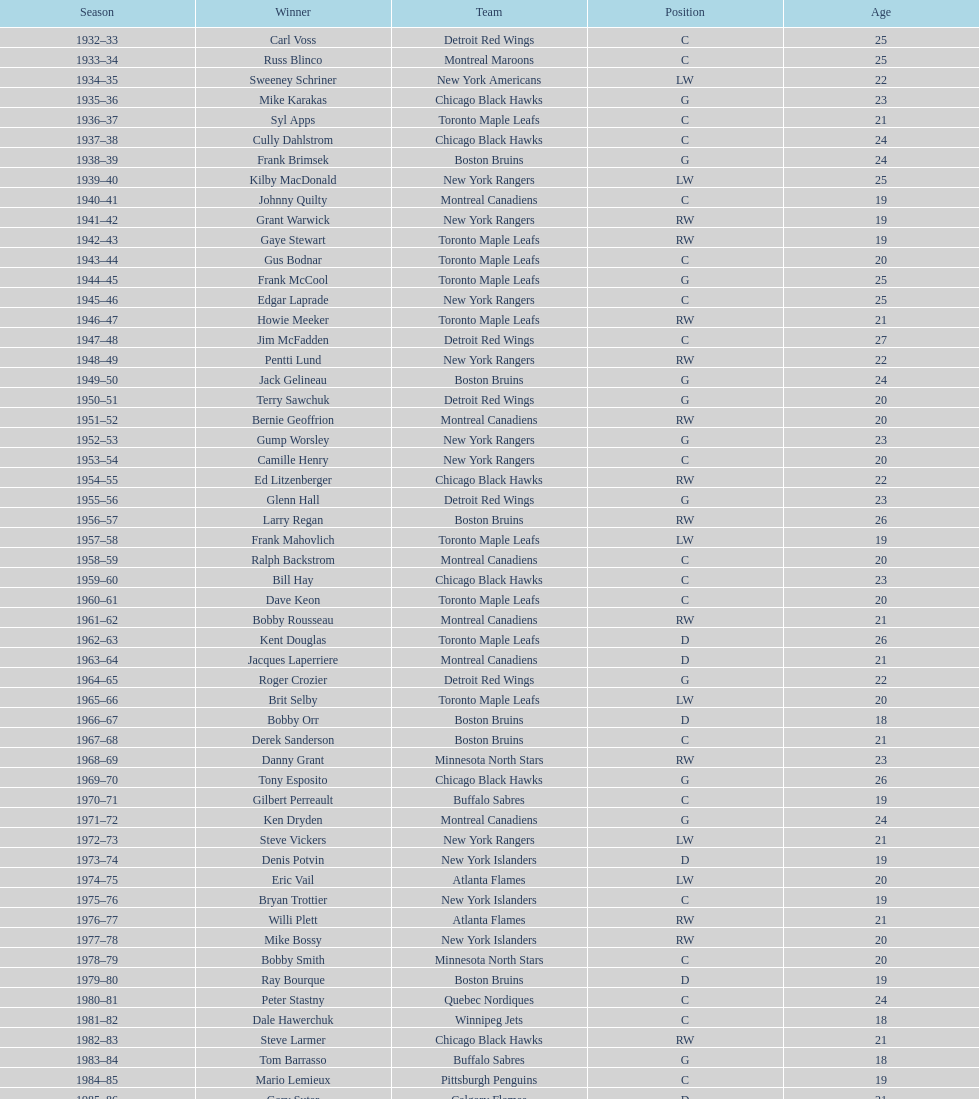What is the total number of toronto maple leafs' victories? 9. Give me the full table as a dictionary. {'header': ['Season', 'Winner', 'Team', 'Position', 'Age'], 'rows': [['1932–33', 'Carl Voss', 'Detroit Red Wings', 'C', '25'], ['1933–34', 'Russ Blinco', 'Montreal Maroons', 'C', '25'], ['1934–35', 'Sweeney Schriner', 'New York Americans', 'LW', '22'], ['1935–36', 'Mike Karakas', 'Chicago Black Hawks', 'G', '23'], ['1936–37', 'Syl Apps', 'Toronto Maple Leafs', 'C', '21'], ['1937–38', 'Cully Dahlstrom', 'Chicago Black Hawks', 'C', '24'], ['1938–39', 'Frank Brimsek', 'Boston Bruins', 'G', '24'], ['1939–40', 'Kilby MacDonald', 'New York Rangers', 'LW', '25'], ['1940–41', 'Johnny Quilty', 'Montreal Canadiens', 'C', '19'], ['1941–42', 'Grant Warwick', 'New York Rangers', 'RW', '19'], ['1942–43', 'Gaye Stewart', 'Toronto Maple Leafs', 'RW', '19'], ['1943–44', 'Gus Bodnar', 'Toronto Maple Leafs', 'C', '20'], ['1944–45', 'Frank McCool', 'Toronto Maple Leafs', 'G', '25'], ['1945–46', 'Edgar Laprade', 'New York Rangers', 'C', '25'], ['1946–47', 'Howie Meeker', 'Toronto Maple Leafs', 'RW', '21'], ['1947–48', 'Jim McFadden', 'Detroit Red Wings', 'C', '27'], ['1948–49', 'Pentti Lund', 'New York Rangers', 'RW', '22'], ['1949–50', 'Jack Gelineau', 'Boston Bruins', 'G', '24'], ['1950–51', 'Terry Sawchuk', 'Detroit Red Wings', 'G', '20'], ['1951–52', 'Bernie Geoffrion', 'Montreal Canadiens', 'RW', '20'], ['1952–53', 'Gump Worsley', 'New York Rangers', 'G', '23'], ['1953–54', 'Camille Henry', 'New York Rangers', 'C', '20'], ['1954–55', 'Ed Litzenberger', 'Chicago Black Hawks', 'RW', '22'], ['1955–56', 'Glenn Hall', 'Detroit Red Wings', 'G', '23'], ['1956–57', 'Larry Regan', 'Boston Bruins', 'RW', '26'], ['1957–58', 'Frank Mahovlich', 'Toronto Maple Leafs', 'LW', '19'], ['1958–59', 'Ralph Backstrom', 'Montreal Canadiens', 'C', '20'], ['1959–60', 'Bill Hay', 'Chicago Black Hawks', 'C', '23'], ['1960–61', 'Dave Keon', 'Toronto Maple Leafs', 'C', '20'], ['1961–62', 'Bobby Rousseau', 'Montreal Canadiens', 'RW', '21'], ['1962–63', 'Kent Douglas', 'Toronto Maple Leafs', 'D', '26'], ['1963–64', 'Jacques Laperriere', 'Montreal Canadiens', 'D', '21'], ['1964–65', 'Roger Crozier', 'Detroit Red Wings', 'G', '22'], ['1965–66', 'Brit Selby', 'Toronto Maple Leafs', 'LW', '20'], ['1966–67', 'Bobby Orr', 'Boston Bruins', 'D', '18'], ['1967–68', 'Derek Sanderson', 'Boston Bruins', 'C', '21'], ['1968–69', 'Danny Grant', 'Minnesota North Stars', 'RW', '23'], ['1969–70', 'Tony Esposito', 'Chicago Black Hawks', 'G', '26'], ['1970–71', 'Gilbert Perreault', 'Buffalo Sabres', 'C', '19'], ['1971–72', 'Ken Dryden', 'Montreal Canadiens', 'G', '24'], ['1972–73', 'Steve Vickers', 'New York Rangers', 'LW', '21'], ['1973–74', 'Denis Potvin', 'New York Islanders', 'D', '19'], ['1974–75', 'Eric Vail', 'Atlanta Flames', 'LW', '20'], ['1975–76', 'Bryan Trottier', 'New York Islanders', 'C', '19'], ['1976–77', 'Willi Plett', 'Atlanta Flames', 'RW', '21'], ['1977–78', 'Mike Bossy', 'New York Islanders', 'RW', '20'], ['1978–79', 'Bobby Smith', 'Minnesota North Stars', 'C', '20'], ['1979–80', 'Ray Bourque', 'Boston Bruins', 'D', '19'], ['1980–81', 'Peter Stastny', 'Quebec Nordiques', 'C', '24'], ['1981–82', 'Dale Hawerchuk', 'Winnipeg Jets', 'C', '18'], ['1982–83', 'Steve Larmer', 'Chicago Black Hawks', 'RW', '21'], ['1983–84', 'Tom Barrasso', 'Buffalo Sabres', 'G', '18'], ['1984–85', 'Mario Lemieux', 'Pittsburgh Penguins', 'C', '19'], ['1985–86', 'Gary Suter', 'Calgary Flames', 'D', '21'], ['1986–87', 'Luc Robitaille', 'Los Angeles Kings', 'LW', '20'], ['1987–88', 'Joe Nieuwendyk', 'Calgary Flames', 'C', '21'], ['1988–89', 'Brian Leetch', 'New York Rangers', 'D', '20'], ['1989–90', 'Sergei Makarov', 'Calgary Flames', 'RW', '31'], ['1990–91', 'Ed Belfour', 'Chicago Blackhawks', 'G', '25'], ['1991–92', 'Pavel Bure', 'Vancouver Canucks', 'RW', '20'], ['1992–93', 'Teemu Selanne', 'Winnipeg Jets', 'RW', '22'], ['1993–94', 'Martin Brodeur', 'New Jersey Devils', 'G', '21'], ['1994–95', 'Peter Forsberg', 'Quebec Nordiques', 'C', '21'], ['1995–96', 'Daniel Alfredsson', 'Ottawa Senators', 'RW', '22'], ['1996–97', 'Bryan Berard', 'New York Islanders', 'D', '19'], ['1997–98', 'Sergei Samsonov', 'Boston Bruins', 'LW', '19'], ['1998–99', 'Chris Drury', 'Colorado Avalanche', 'C', '22'], ['1999–2000', 'Scott Gomez', 'New Jersey Devils', 'C', '19'], ['2000–01', 'Evgeni Nabokov', 'San Jose Sharks', 'G', '25'], ['2001–02', 'Dany Heatley', 'Atlanta Thrashers', 'RW', '20'], ['2002–03', 'Barret Jackman', 'St. Louis Blues', 'D', '21'], ['2003–04', 'Andrew Raycroft', 'Boston Bruins', 'G', '23'], ['2004–05', 'No winner because of the\\n2004–05 NHL lockout', '-', '-', '-'], ['2005–06', 'Alexander Ovechkin', 'Washington Capitals', 'LW', '20'], ['2006–07', 'Evgeni Malkin', 'Pittsburgh Penguins', 'C', '20'], ['2007–08', 'Patrick Kane', 'Chicago Blackhawks', 'RW', '19'], ['2008–09', 'Steve Mason', 'Columbus Blue Jackets', 'G', '21'], ['2009–10', 'Tyler Myers', 'Buffalo Sabres', 'D', '20'], ['2010–11', 'Jeff Skinner', 'Carolina Hurricanes', 'C', '18'], ['2011–12', 'Gabriel Landeskog', 'Colorado Avalanche', 'LW', '19'], ['2012–13', 'Jonathan Huberdeau', 'Florida Panthers', 'C', '19']]} 